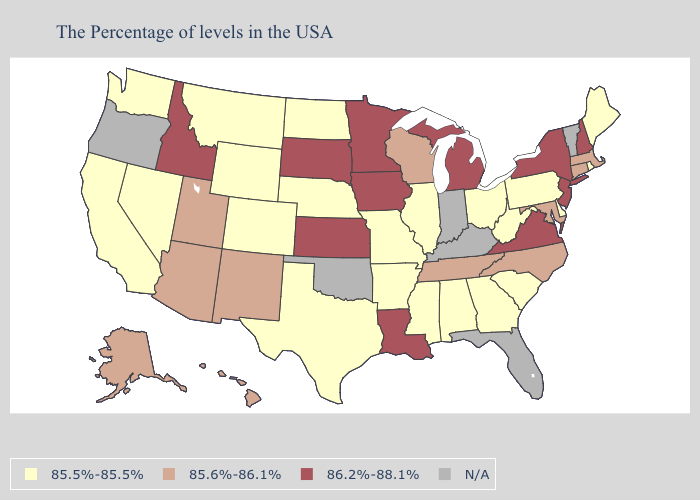Among the states that border Arizona , does California have the lowest value?
Short answer required. Yes. Does Idaho have the lowest value in the USA?
Short answer required. No. Does Rhode Island have the lowest value in the USA?
Concise answer only. Yes. Name the states that have a value in the range 86.2%-88.1%?
Give a very brief answer. New Hampshire, New York, New Jersey, Virginia, Michigan, Louisiana, Minnesota, Iowa, Kansas, South Dakota, Idaho. Name the states that have a value in the range 85.5%-85.5%?
Short answer required. Maine, Rhode Island, Delaware, Pennsylvania, South Carolina, West Virginia, Ohio, Georgia, Alabama, Illinois, Mississippi, Missouri, Arkansas, Nebraska, Texas, North Dakota, Wyoming, Colorado, Montana, Nevada, California, Washington. What is the highest value in the USA?
Keep it brief. 86.2%-88.1%. What is the value of New Jersey?
Give a very brief answer. 86.2%-88.1%. What is the value of Kentucky?
Answer briefly. N/A. What is the value of Idaho?
Write a very short answer. 86.2%-88.1%. Does the map have missing data?
Write a very short answer. Yes. Among the states that border Montana , which have the lowest value?
Quick response, please. North Dakota, Wyoming. What is the value of Illinois?
Short answer required. 85.5%-85.5%. Name the states that have a value in the range N/A?
Be succinct. Vermont, Florida, Kentucky, Indiana, Oklahoma, Oregon. What is the value of Iowa?
Write a very short answer. 86.2%-88.1%. 